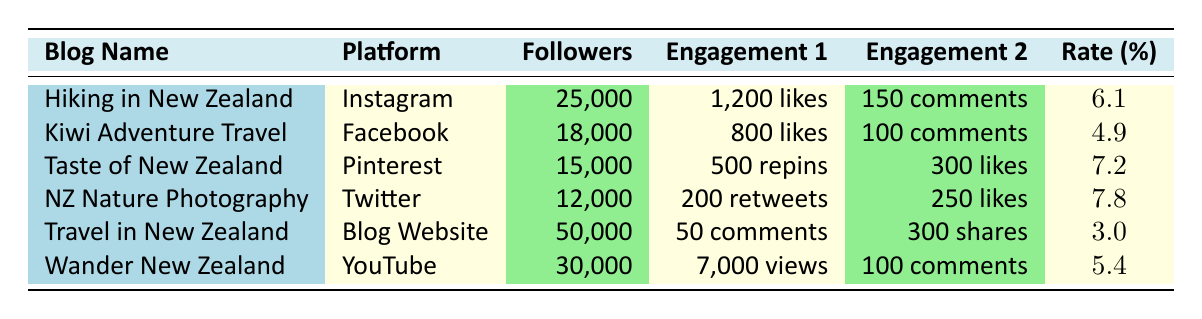What is the highest engagement rate among the blogs listed? Looking at the engagement rates in the table, "New Zealand Nature Photography" has the highest rate of 7.8%.
Answer: 7.8% Which blog has the most followers on social media? The table shows that "Travel in New Zealand" has the most followers with 50,000.
Answer: 50,000 What is the average number of likes per post on "Hiking in New Zealand"? According to the table, "Hiking in New Zealand" averages 1,200 likes per post.
Answer: 1,200 Is the engagement rate for "Kiwi Adventure Travel" greater than 5%? The engagement rate for "Kiwi Adventure Travel" is 4.9%, which is not greater than 5%.
Answer: No What is the difference in followers between "Hiking in New Zealand" and "New Zealand Nature Photography"? "Hiking in New Zealand" has 25,000 followers, and "New Zealand Nature Photography" has 12,000 followers. The difference is 25,000 - 12,000 = 13,000.
Answer: 13,000 Which blog on which platform has the highest number of comments per post? The table indicates that "Hiking in New Zealand" has 150 comments per post, which is the highest compared to the others listed.
Answer: 150 What is the total number of followers for the three blogs with the highest engagement rates? The three blogs with the highest engagement rates are "New Zealand Nature Photography" (12,000), "Taste of New Zealand" (15,000), and "Hiking in New Zealand" (25,000). Summing these gives 12,000 + 15,000 + 25,000 = 52,000.
Answer: 52,000 Is the average views per video for "Wander New Zealand" above 6,000? "Wander New Zealand" has an average of 7,000 views per video, which is above 6,000.
Answer: Yes What is the average engagement rate of the blogs listed? To find the average engagement rate, we sum the rates: 6.1 + 4.9 + 7.2 + 7.8 + 3.0 + 5.4 = 34.4. Dividing by the number of blogs (6), we get 34.4 / 6 = 5.73.
Answer: 5.73 Which social media platform has the least number of followers in this list? "New Zealand Nature Photography" is on Twitter with the least number of followers, which is 12,000.
Answer: 12,000 